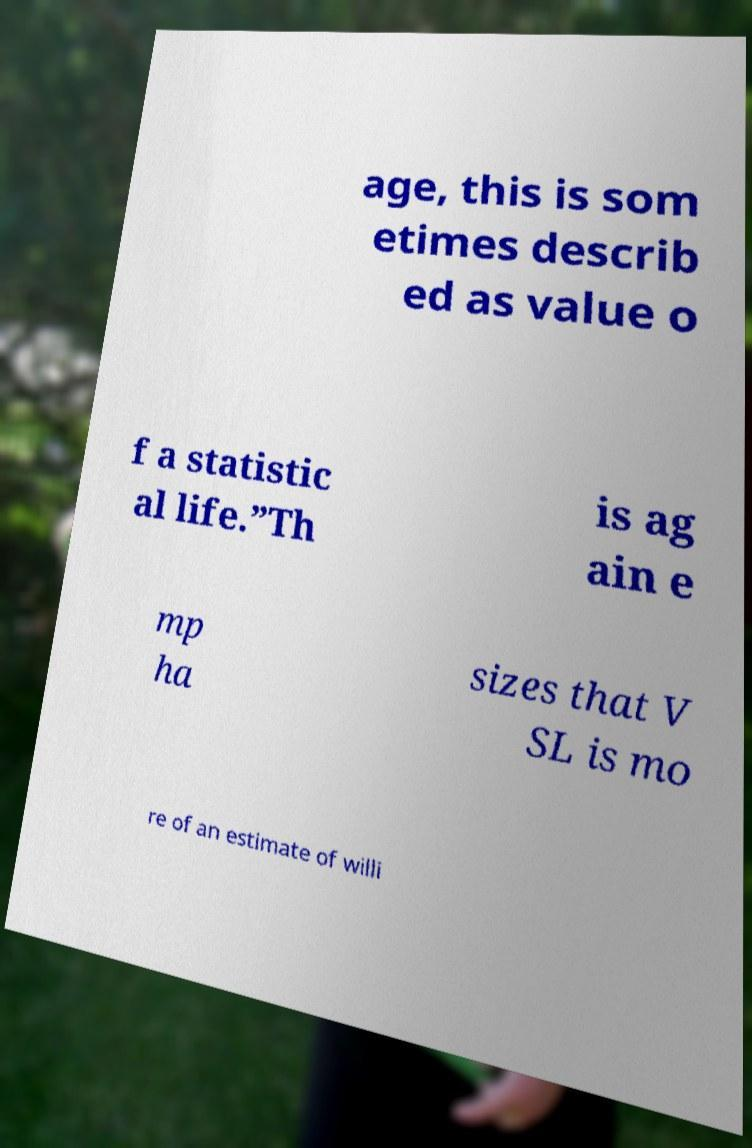Could you extract and type out the text from this image? age, this is som etimes describ ed as value o f a statistic al life.”Th is ag ain e mp ha sizes that V SL is mo re of an estimate of willi 